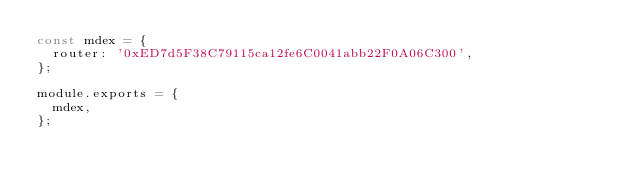<code> <loc_0><loc_0><loc_500><loc_500><_JavaScript_>const mdex = {
  router: '0xED7d5F38C79115ca12fe6C0041abb22F0A06C300',
};

module.exports = {
  mdex,
};
</code> 